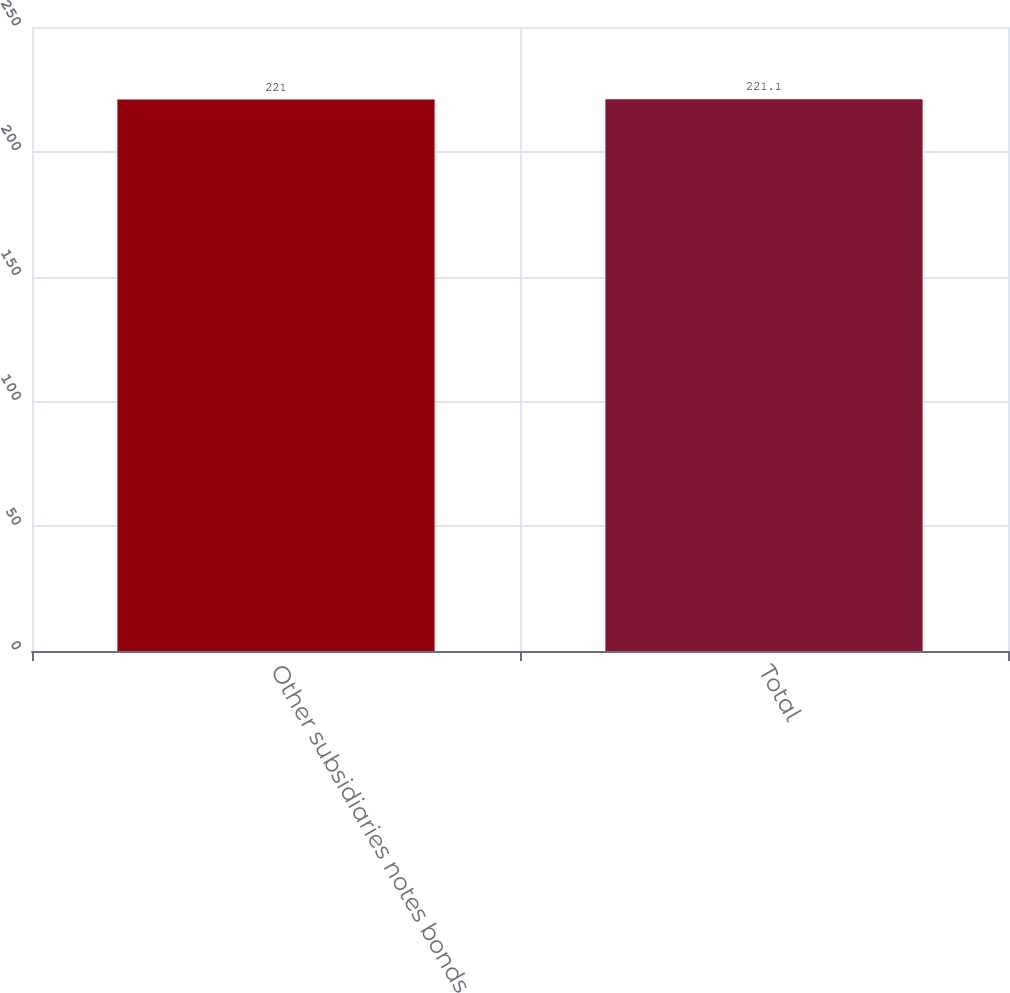Convert chart to OTSL. <chart><loc_0><loc_0><loc_500><loc_500><bar_chart><fcel>Other subsidiaries notes bonds<fcel>Total<nl><fcel>221<fcel>221.1<nl></chart> 